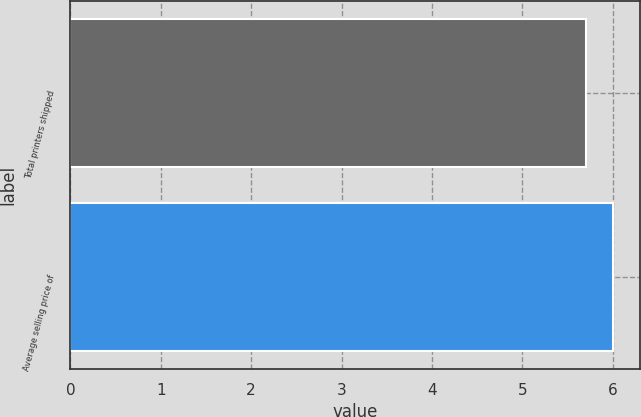<chart> <loc_0><loc_0><loc_500><loc_500><bar_chart><fcel>Total printers shipped<fcel>Average selling price of<nl><fcel>5.7<fcel>6<nl></chart> 